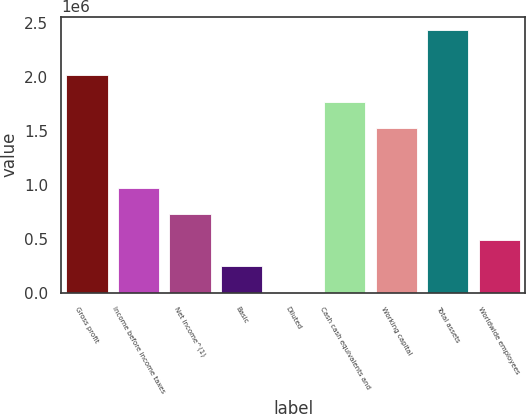Convert chart. <chart><loc_0><loc_0><loc_500><loc_500><bar_chart><fcel>Gross profit<fcel>Income before income taxes<fcel>Net income^(1)<fcel>Basic<fcel>Diluted<fcel>Cash cash equivalents and<fcel>Working capital<fcel>Total assets<fcel>Worldwide employees<nl><fcel>2.01698e+06<fcel>976127<fcel>732095<fcel>244033<fcel>1.19<fcel>1.77295e+06<fcel>1.52892e+06<fcel>2.44032e+06<fcel>488064<nl></chart> 